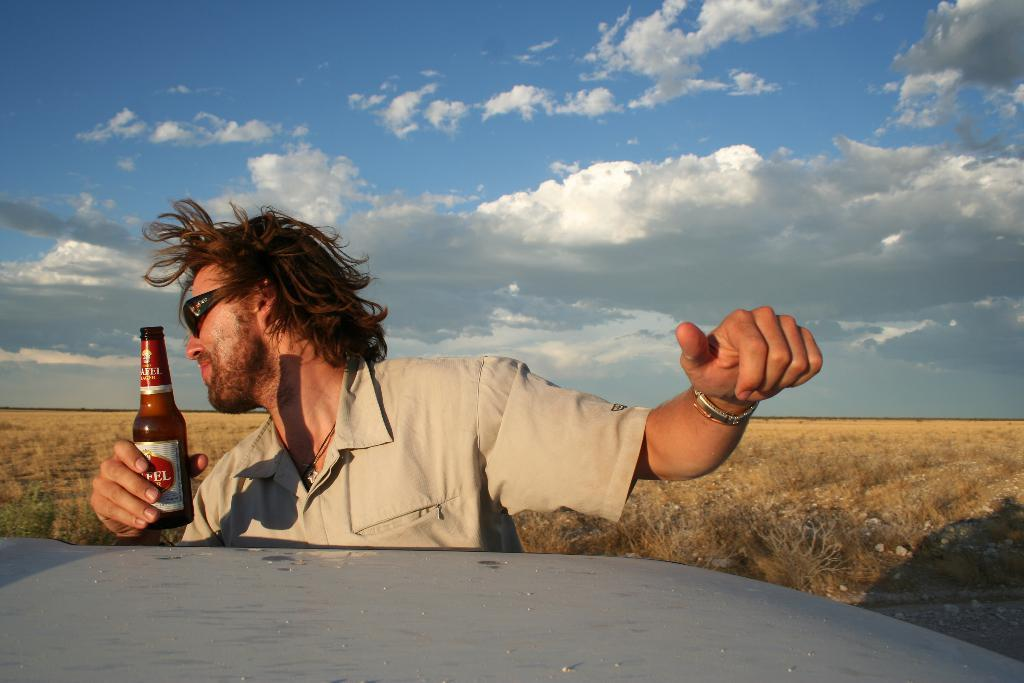What is the main subject in the center of the image? There is a man standing in the center of the image. What is the man holding in the image? The man is holding a bottle. What can be seen at the bottom of the image? There is a vehicle at the bottom of the image. What type of natural environment is visible in the background of the image? There is grass in the background of the image. What is visible in the sky in the background of the image? The sky is visible in the background of the image. What type of jeans is the judge wearing in the image? There is no judge present in the image, and therefore no one is wearing jeans. 